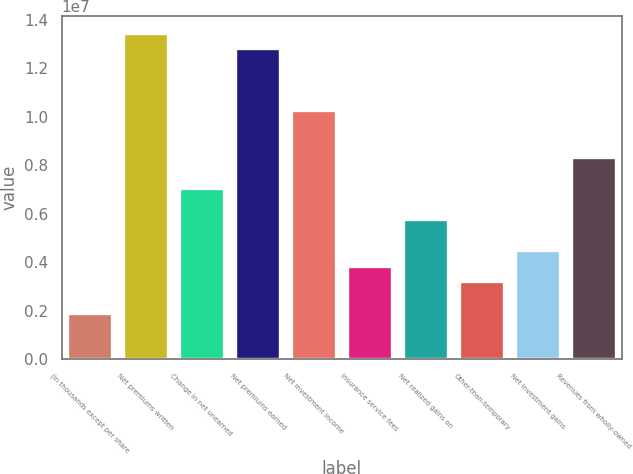Convert chart. <chart><loc_0><loc_0><loc_500><loc_500><bar_chart><fcel>(In thousands except per share<fcel>Net premiums written<fcel>Change in net unearned<fcel>Net premiums earned<fcel>Net investment income<fcel>Insurance service fees<fcel>Net realized gains on<fcel>Other-than-temporary<fcel>Net investment gains<fcel>Revenues from wholly-owned<nl><fcel>1.92256e+06<fcel>1.34579e+07<fcel>7.04939e+06<fcel>1.28171e+07<fcel>1.02537e+07<fcel>3.84512e+06<fcel>5.76768e+06<fcel>3.20427e+06<fcel>4.48597e+06<fcel>8.33109e+06<nl></chart> 